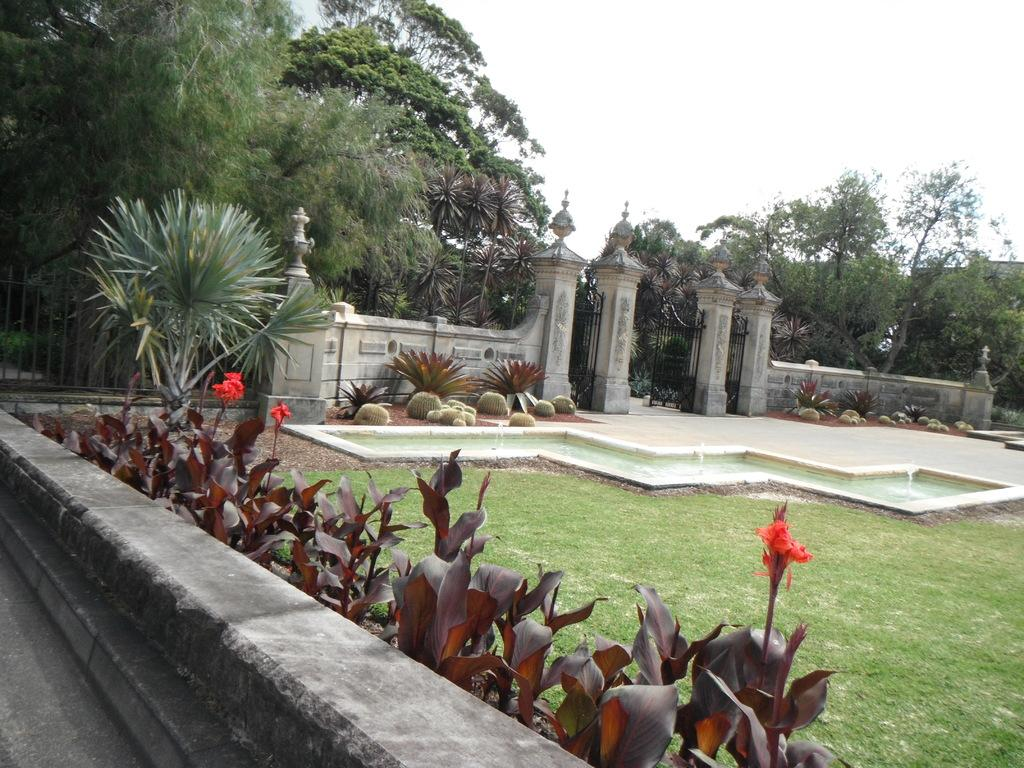What is located in the foreground of the image? There are plants behind a stone surface in the foreground of the image. What type of terrain can be seen in the image? There is grassland visible in the image. What water feature is present in the image? There is a fountain in the image. What type of vegetation is present in the image? There are plants and trees in the image. What architectural features can be seen in the image? There is a wall and a gate in the image. What part of the natural environment is visible in the image? The sky is visible in the image. How many beads are arranged on the fish in the image? There are no beads or fish present in the image. What are the girls doing in the image? There are no girls present in the image. 